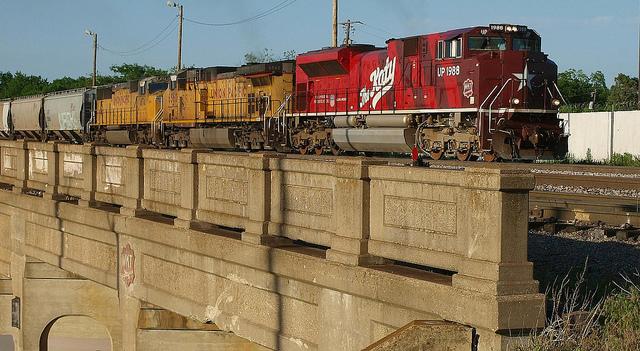What color is the front of the train?
Concise answer only. Red. Is the train still in operation?
Give a very brief answer. Yes. Does this train blow steam?
Give a very brief answer. No. What color is the middle car?
Be succinct. Yellow. What color is the engine?
Short answer required. Red. How many trains are there?
Be succinct. 1. What does the furniture rest in?
Answer briefly. No furniture. Is this an ocean transporter?
Concise answer only. No. Are the tracks on natural ground?
Keep it brief. No. 